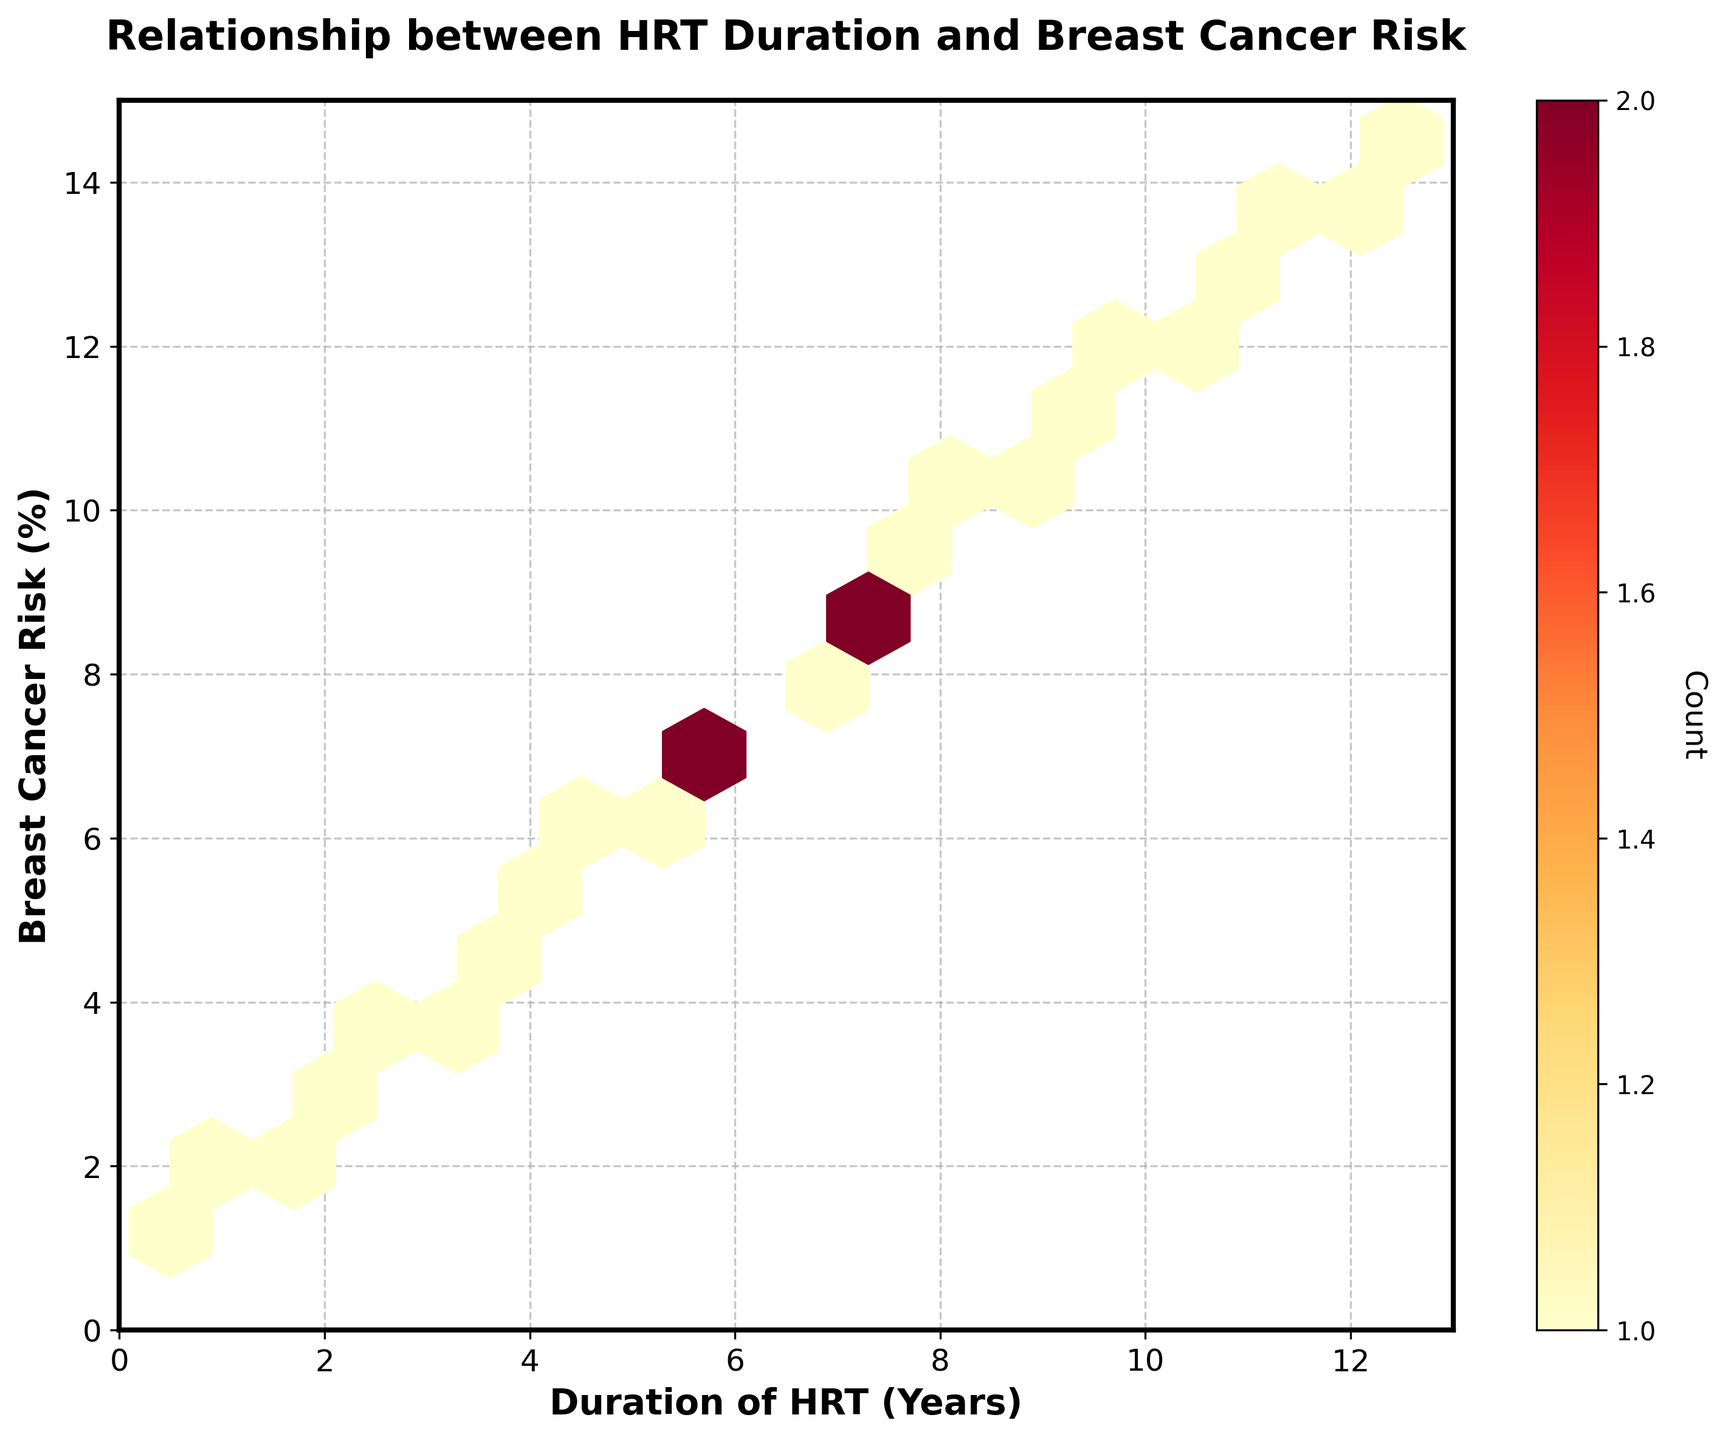What's the title of the plot? The title of the plot is displayed at the top of the figure in bold and larger font size, making it easy to identify.
Answer: Relationship between HRT Duration and Breast Cancer Risk What do the x and y axes represent? The x-axis label "Duration of HRT (Years)" indicates it represents the duration one undergoes hormone replacement therapy in years. The y-axis label "Breast Cancer Risk (%)" signifies it shows the risk of breast cancer as a percentage.
Answer: Duration of HRT (Years) and Breast Cancer Risk (%) What color scheme is used in the plot? The color scheme for the hexbin plot ranges from yellow to orange to red, as denoted by 'YlOrRd' in the color mapping. This range indicates the density of points increasing from yellow (less dense) to red (more dense).
Answer: Yellow to red How are the highest-density areas visually represented in the plot? The highest-density areas are represented by the darkest red colors in the hexbin plot, indicating where most data points are concentrated.
Answer: Dark red What is the count label on the color bar axis? The color bar on the right side of the plot shows density rather than numerical data points directly, but it is titled "Count" with its label rotated to align vertically.
Answer: Count How many different x-axis tick values are there within the plot's limit? By observing the x-axis, it shows tick values marked at intervals from 0 to 13.
Answer: 14 Is there a visible trend between HRT duration and breast cancer risk? The plot visually shows an increasing trend where the longer the duration of hormone replacement therapy, the higher the breast cancer risk. This is evident as the data points move upwards along the y-axis as the x-axis value increases.
Answer: Yes, there's an increasing trend What is the approximate cancer risk percentile at 5 years of HRT duration? By locating the x value of 5 years on the hexbin plot, the corresponding y value can be approximated around 6.2%, indicating breast cancer risk rises to about 6.2% after 5 years of HRT.
Answer: Around 6.2% Compare the breast cancer risk at 2 years and 10 years of HRT duration. By comparing the y-values corresponding to 2 years and 10 years on the x-axis, at 2 years, the risk is around 2.9%, and at 10 years, it’s about 11.7%. Hence, the breast cancer risk increases significantly from 2.9% to 11.7%.
Answer: 2.9% at 2 years and 11.7% at 10 years What do the gridlines in the plot help with? The gridlines, drawn faintly but consistently across the plot, help in tracking and accurately reading the positions of data points, making it easier to align and interpret the x and y values.
Answer: Track positions and interpret values 